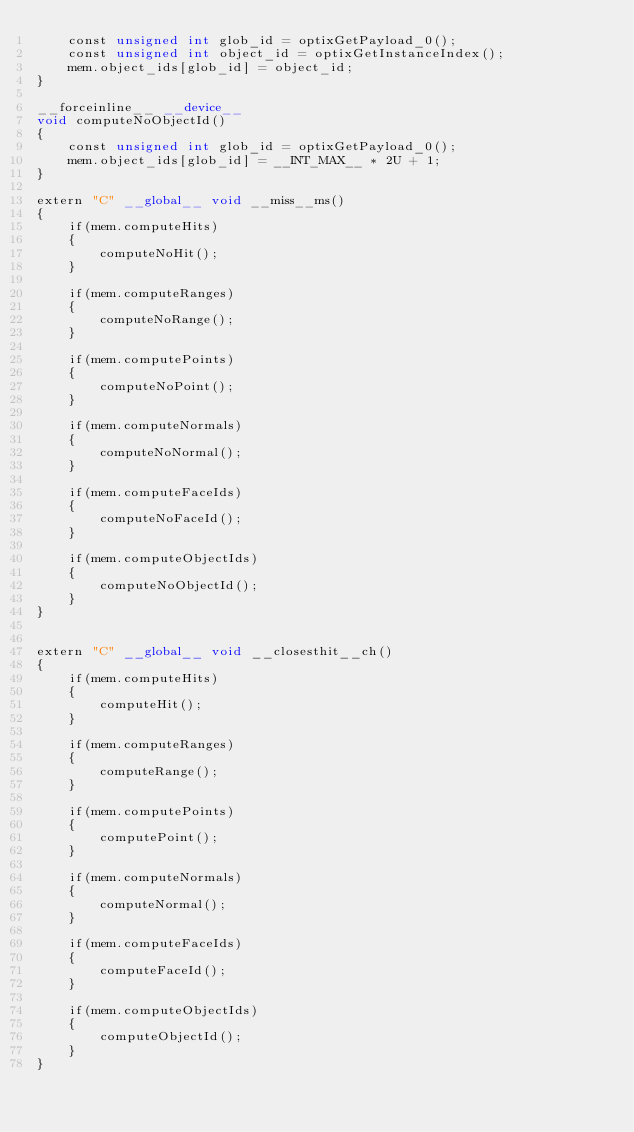Convert code to text. <code><loc_0><loc_0><loc_500><loc_500><_Cuda_>    const unsigned int glob_id = optixGetPayload_0();
    const unsigned int object_id = optixGetInstanceIndex();
    mem.object_ids[glob_id] = object_id;
}

__forceinline__ __device__
void computeNoObjectId()
{
    const unsigned int glob_id = optixGetPayload_0();
    mem.object_ids[glob_id] = __INT_MAX__ * 2U + 1;
}

extern "C" __global__ void __miss__ms()
{
    if(mem.computeHits)
    {
        computeNoHit();
    }

    if(mem.computeRanges)
    {
        computeNoRange();
    }

    if(mem.computePoints)
    {
        computeNoPoint();
    }

    if(mem.computeNormals)
    {
        computeNoNormal();
    }

    if(mem.computeFaceIds)
    {
        computeNoFaceId();
    }

    if(mem.computeObjectIds)
    {
        computeNoObjectId();
    }
}


extern "C" __global__ void __closesthit__ch()
{
    if(mem.computeHits)
    {
        computeHit();
    }

    if(mem.computeRanges)
    {
        computeRange();
    }

    if(mem.computePoints)
    {
        computePoint();
    }

    if(mem.computeNormals)
    {
        computeNormal();
    }

    if(mem.computeFaceIds)
    {
        computeFaceId();
    }

    if(mem.computeObjectIds)
    {
        computeObjectId();
    }
}
</code> 